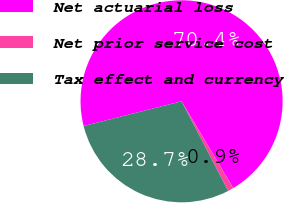Convert chart. <chart><loc_0><loc_0><loc_500><loc_500><pie_chart><fcel>Net actuarial loss<fcel>Net prior service cost<fcel>Tax effect and currency<nl><fcel>70.39%<fcel>0.92%<fcel>28.69%<nl></chart> 